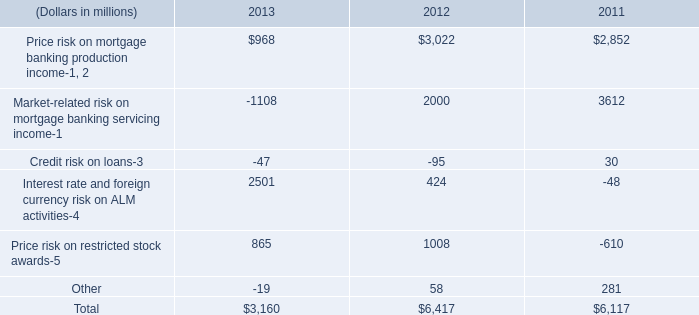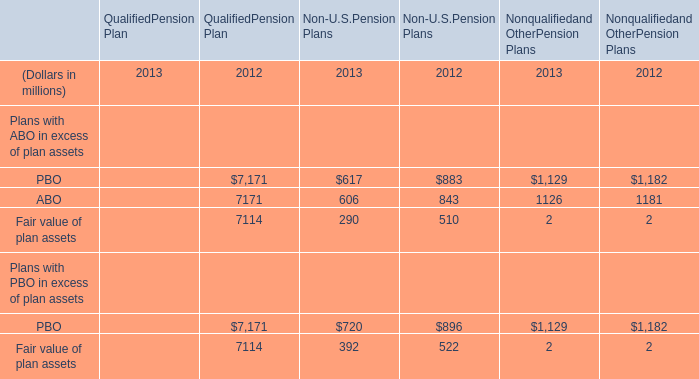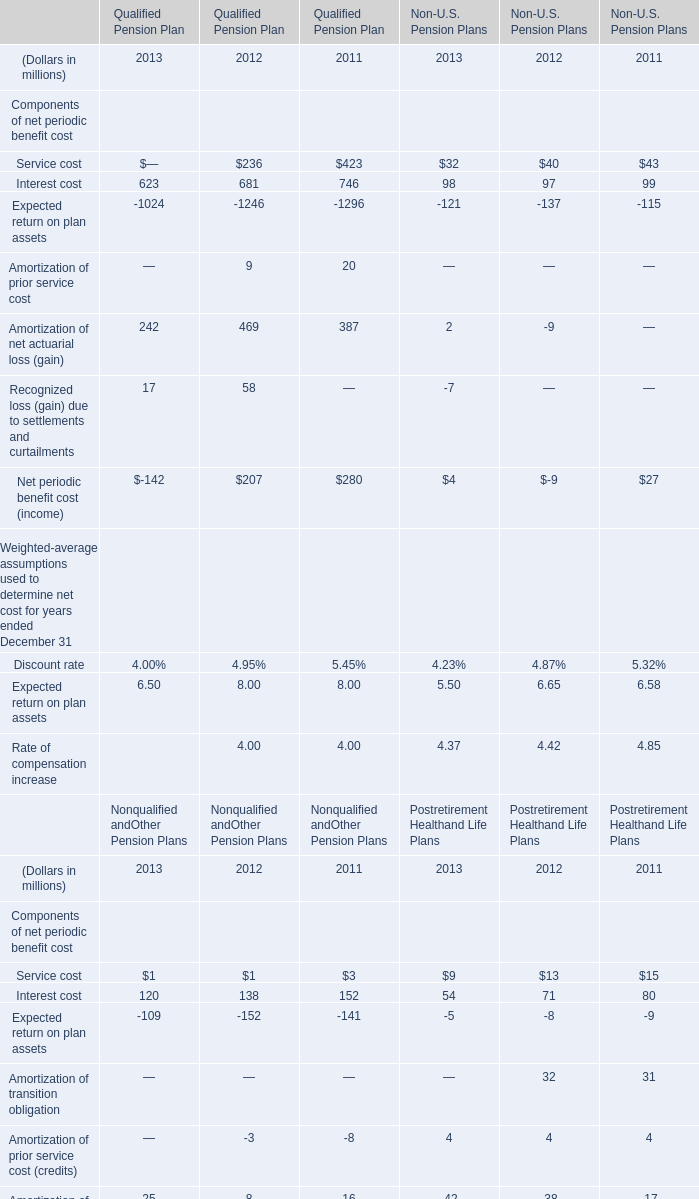If Interest cost of Qualified Pension Plan develops with the same growth rate in 2013, what will it reach in 2014? (in million) 
Computations: (623 * (1 + ((623 - 681) / 681)))
Answer: 569.93979. 